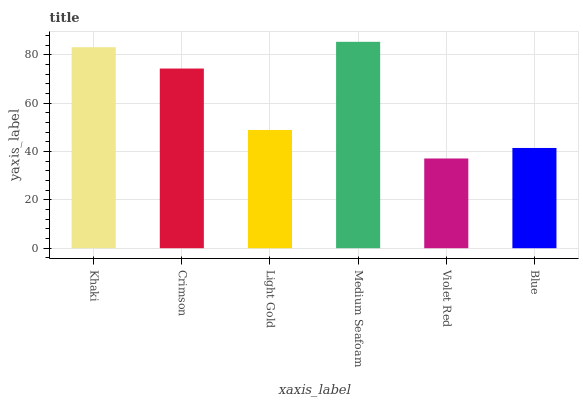Is Violet Red the minimum?
Answer yes or no. Yes. Is Medium Seafoam the maximum?
Answer yes or no. Yes. Is Crimson the minimum?
Answer yes or no. No. Is Crimson the maximum?
Answer yes or no. No. Is Khaki greater than Crimson?
Answer yes or no. Yes. Is Crimson less than Khaki?
Answer yes or no. Yes. Is Crimson greater than Khaki?
Answer yes or no. No. Is Khaki less than Crimson?
Answer yes or no. No. Is Crimson the high median?
Answer yes or no. Yes. Is Light Gold the low median?
Answer yes or no. Yes. Is Blue the high median?
Answer yes or no. No. Is Violet Red the low median?
Answer yes or no. No. 